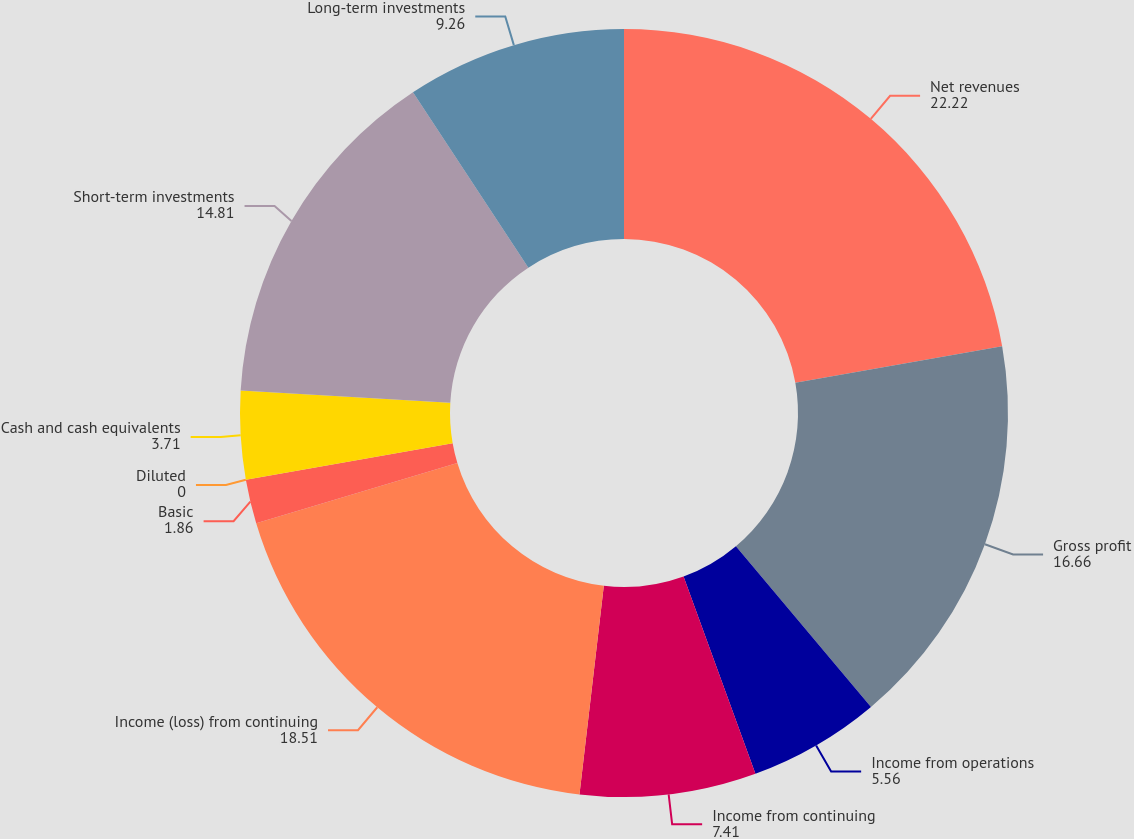<chart> <loc_0><loc_0><loc_500><loc_500><pie_chart><fcel>Net revenues<fcel>Gross profit<fcel>Income from operations<fcel>Income from continuing<fcel>Income (loss) from continuing<fcel>Basic<fcel>Diluted<fcel>Cash and cash equivalents<fcel>Short-term investments<fcel>Long-term investments<nl><fcel>22.22%<fcel>16.66%<fcel>5.56%<fcel>7.41%<fcel>18.51%<fcel>1.86%<fcel>0.0%<fcel>3.71%<fcel>14.81%<fcel>9.26%<nl></chart> 